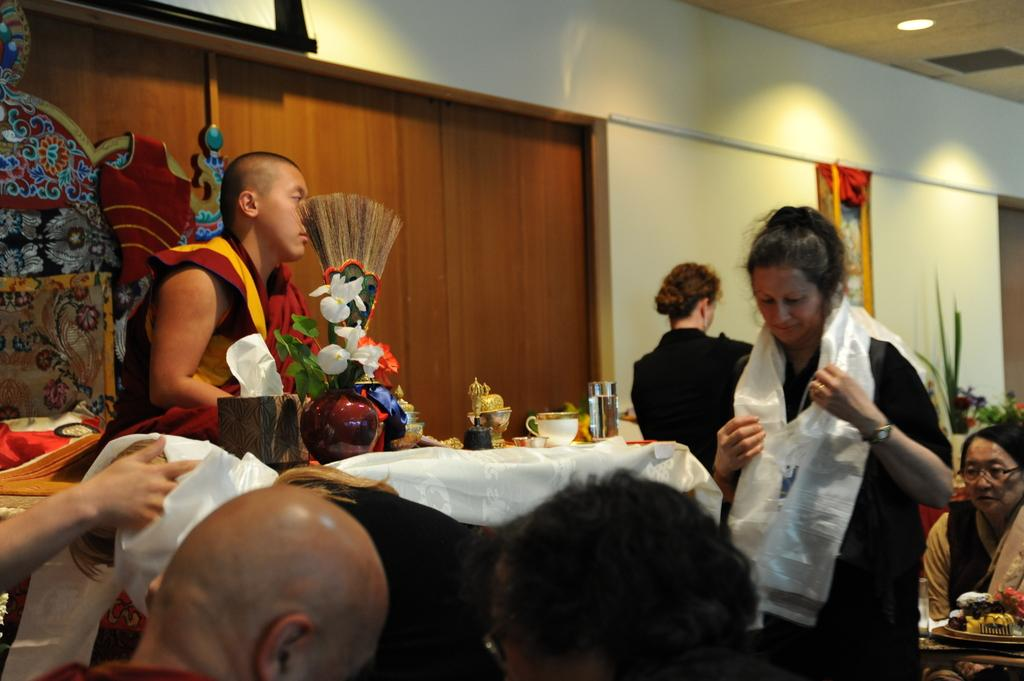What is the color of the wall in the image? The wall in the image is white. What are the people in the image doing? The people in the image are sitting on chairs. What furniture is present in the image? There is a table in the image. What objects can be seen on the table? There is a flower flask, a cup, and a glass on the table. How many horses are present in the image? There are no horses present in the image. What type of secretary is working at the table in the image? There is no secretary present in the image. 